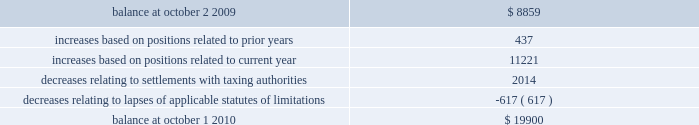31mar201122064257 notes to consolidated financial statements ( continued ) 10 .
Income taxes ( continued ) a reconciliation of the beginning and ending amount of gross unrecognized tax benefits is as follows ( in thousands ) : .
The company 2019s major tax jurisdictions as of october 1 , 2010 are the united states , california , and iowa .
For the united states , the company has open tax years dating back to fiscal year 1998 due to the carry forward of tax attributes .
For california and iowa , the company has open tax years dating back to fiscal year 2002 due to the carry forward of tax attributes .
During the year ended october 1 , 2010 , $ 0.6 million of previously unrecognized tax benefits related to the expiration of the statute of limitations period were recognized .
The company 2019s policy is to recognize accrued interest and penalties , if incurred , on any unrecognized tax benefits as a component of income tax expense .
The company did not incur any significant accrued interest or penalties related to unrecognized tax benefits during fiscal year 2010 .
11 .
Stockholders 2019 equity common stock the company is authorized to issue ( 1 ) 525000000 shares of common stock , par value $ 0.25 per share , and ( 2 ) 25000000 shares of preferred stock , without par value .
Holders of the company 2019s common stock are entitled to such dividends as may be declared by the company 2019s board of directors out of funds legally available for such purpose .
Dividends may not be paid on common stock unless all accrued dividends on preferred stock , if any , have been paid or declared and set aside .
In the event of the company 2019s liquidation , dissolution or winding up , the holders of common stock will be entitled to share pro rata in the assets remaining after payment to creditors and after payment of the liquidation preference plus any unpaid dividends to holders of any outstanding preferred stock .
Each holder of the company 2019s common stock is entitled to one vote for each such share outstanding in the holder 2019s name .
No holder of common stock is entitled to cumulate votes in voting for directors .
The company 2019s second amended and restated certificate of incorporation provides that , unless otherwise determined by the company 2019s board of directors , no holder of common stock has any preemptive right to purchase or subscribe for any stock of any class which the company may issue or on august 3 , 2010 , the company 2019s board of directors approved a stock repurchase program , pursuant to which the company is authorized to repurchase up to $ 200 million of the company 2019s common stock from time to time on the open market or in privately negotiated transactions as permitted by securities laws and other legal requirements .
The company had not repurchased any shares under the program for the fiscal year ended october 1 , 2010 .
As of november 29 , 2010 , the skyworks / 2010 annual report 137 .
What is the net chance in the balance of gross unrecognized tax benefits from 2009 to 2010? 
Computations: (19900 - 8859)
Answer: 11041.0. 